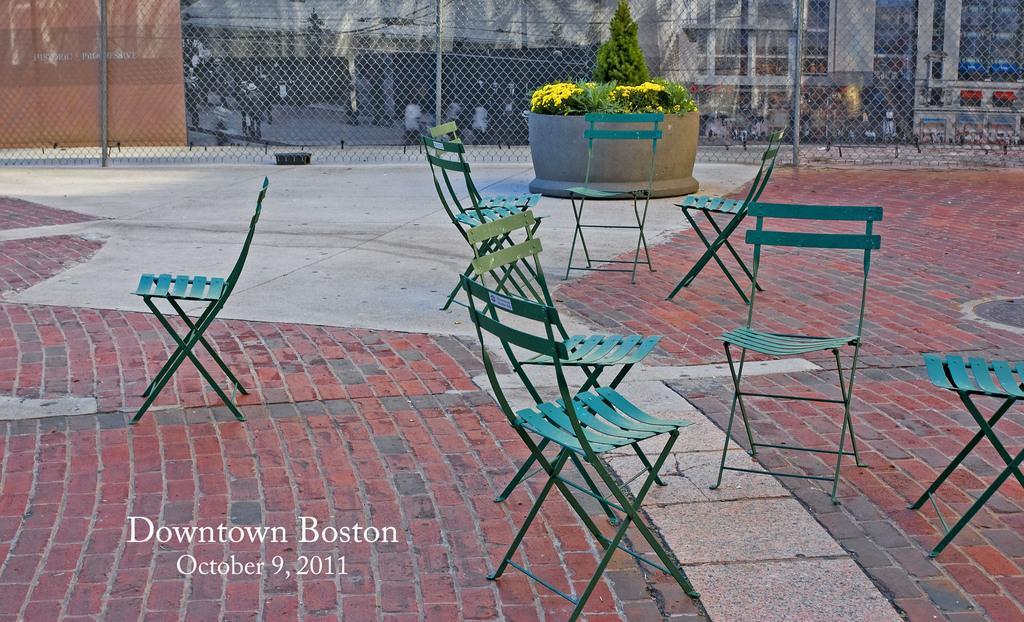How would you summarize this image in a sentence or two? this picture shows few chairs to sit and a plant and a metal fence around and we see a building 